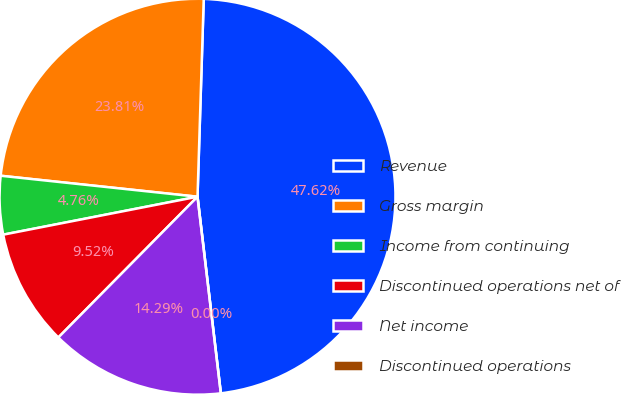<chart> <loc_0><loc_0><loc_500><loc_500><pie_chart><fcel>Revenue<fcel>Gross margin<fcel>Income from continuing<fcel>Discontinued operations net of<fcel>Net income<fcel>Discontinued operations<nl><fcel>47.62%<fcel>23.81%<fcel>4.76%<fcel>9.52%<fcel>14.29%<fcel>0.0%<nl></chart> 